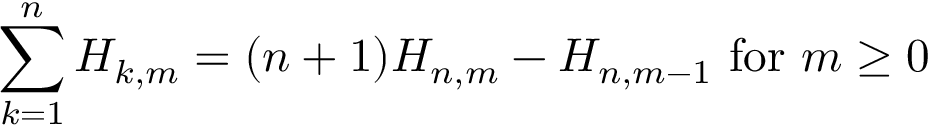<formula> <loc_0><loc_0><loc_500><loc_500>\sum _ { k = 1 } ^ { n } H _ { k , m } = ( n + 1 ) H _ { n , m } - H _ { n , m - 1 } { f o r } m \geq 0</formula> 